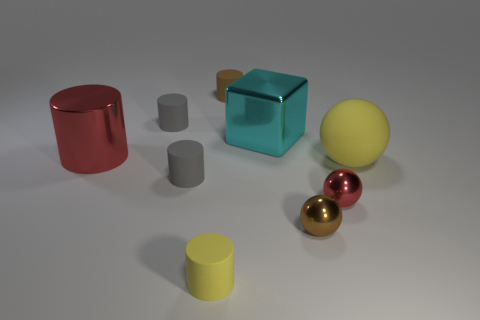Subtract all brown cylinders. How many cylinders are left? 4 Subtract all metal cylinders. How many cylinders are left? 4 Subtract 1 cyan blocks. How many objects are left? 8 Subtract all balls. How many objects are left? 6 Subtract 1 cubes. How many cubes are left? 0 Subtract all brown balls. Subtract all brown blocks. How many balls are left? 2 Subtract all purple cylinders. How many blue cubes are left? 0 Subtract all big spheres. Subtract all tiny red shiny balls. How many objects are left? 7 Add 9 tiny red shiny balls. How many tiny red shiny balls are left? 10 Add 7 yellow rubber cylinders. How many yellow rubber cylinders exist? 8 